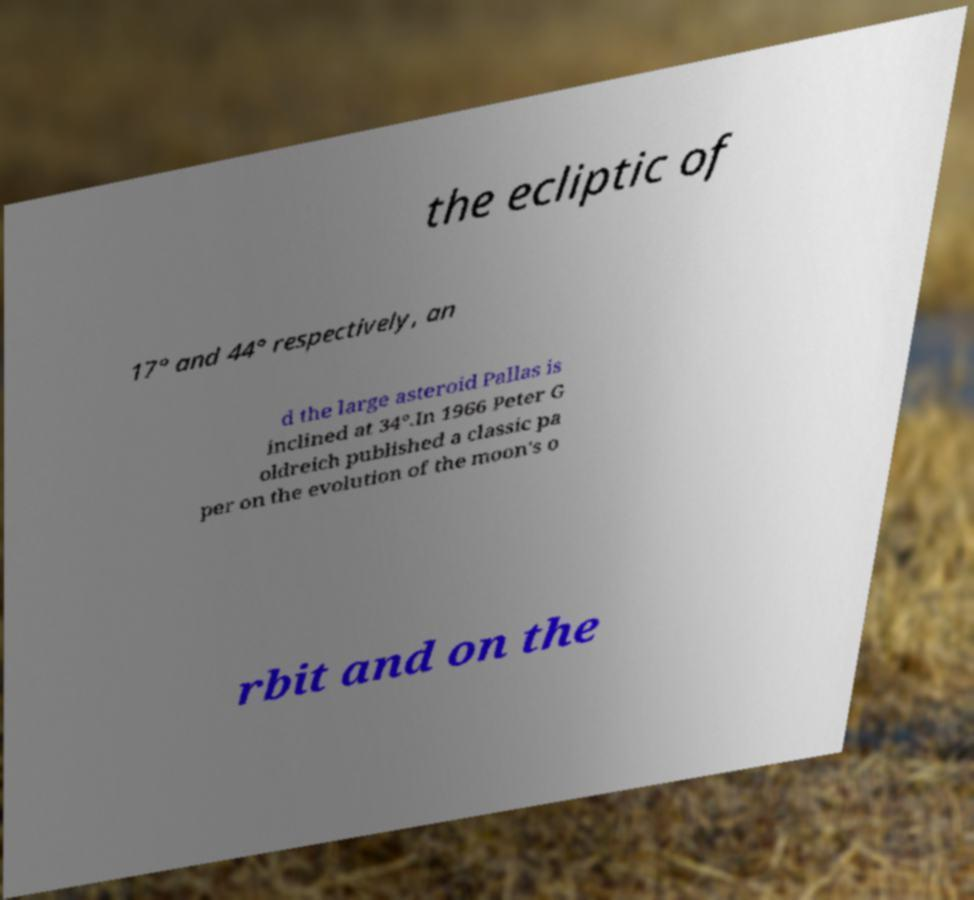I need the written content from this picture converted into text. Can you do that? the ecliptic of 17° and 44° respectively, an d the large asteroid Pallas is inclined at 34°.In 1966 Peter G oldreich published a classic pa per on the evolution of the moon's o rbit and on the 